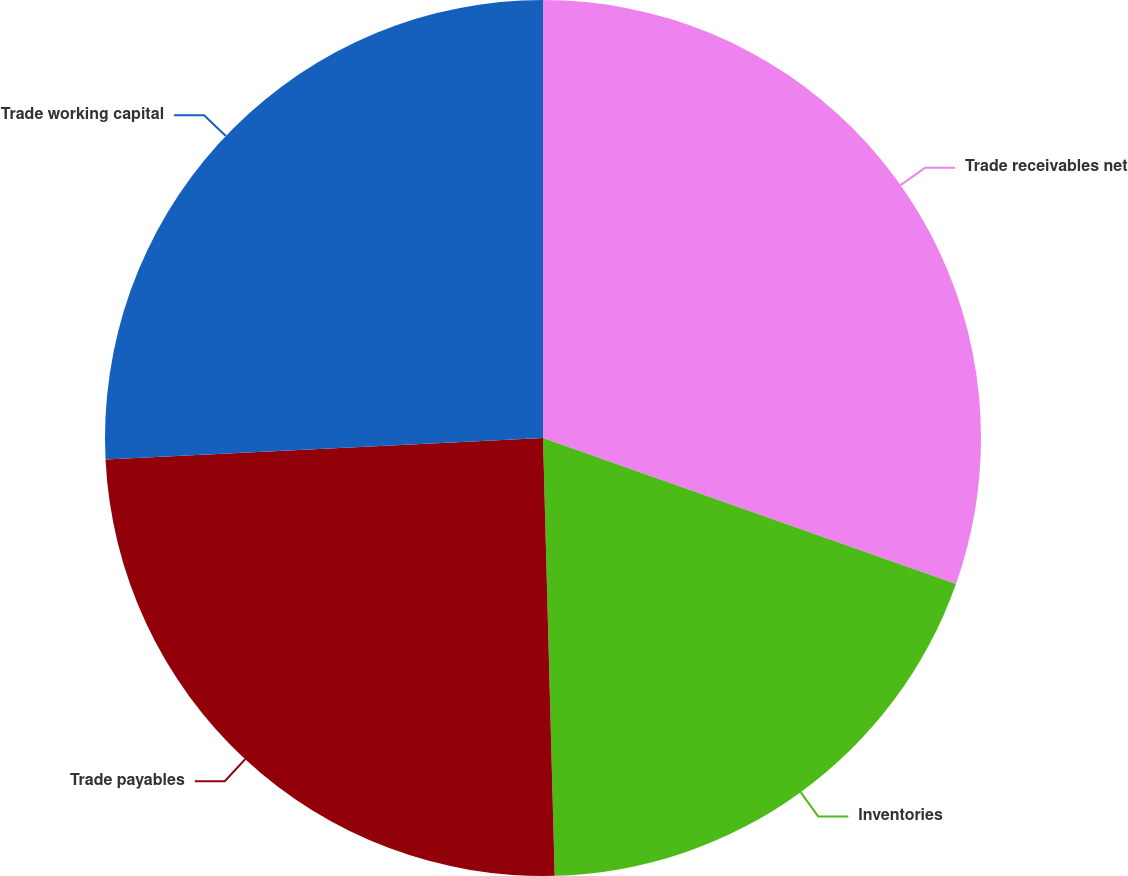<chart> <loc_0><loc_0><loc_500><loc_500><pie_chart><fcel>Trade receivables net<fcel>Inventories<fcel>Trade payables<fcel>Trade working capital<nl><fcel>30.41%<fcel>19.17%<fcel>24.65%<fcel>25.78%<nl></chart> 